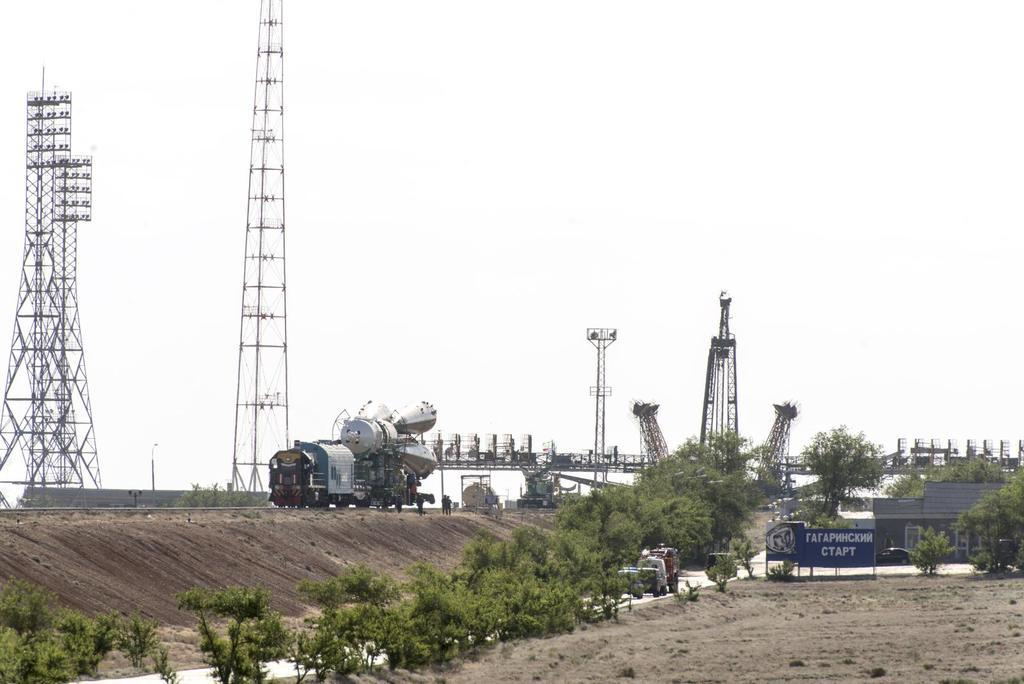What is located in the center of the image? There are towers and a vehicle in the center of the image. What type of terrain is visible in the image? There is sand visible in the image. What type of vegetation is present in the image? There are trees in the image. What is written on the board in the image? There is a board with text in the image. What is the board resting on in the image? The bottom of the board has sand, and the top has sky. Can you see a laborer using a swing in the image? There is no laborer or swing present in the image. Is there a snake visible in the image? There is no snake present in the image. 